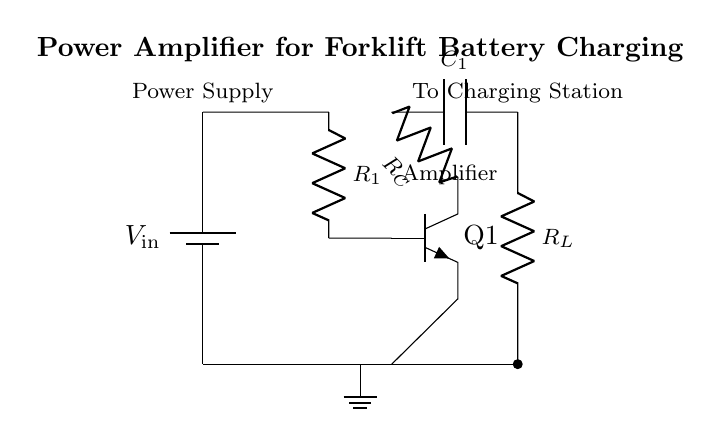What is the input voltage of the circuit? The input voltage is labeled as \( V_{\text{in}} \) and is a key parameter in the circuit that determines the power supplied to the amplifier.
Answer: \( V_{\text{in}} \) What type of transistor is used in this circuit? The component labeled as Q1 is identified as an npn transistor, which is commonly used in amplifying configurations due to its ability to handle high current gain.
Answer: npn What is the role of capacitor C1 in the circuit? Capacitor C1 is primarily used for coupling, allowing AC signals to pass from the amplifier stage to the output while blocking DC, thus preserving the functionality of the amplifier.
Answer: Coupling What components are used in the output stage? The output stage of the circuit consists of the load resistor \( R_L \) which connects the output of the amplifier to the charging station.
Answer: \( R_L \) How many resistors are present in this circuit? There are two resistors in this specific amplifier circuit, \( R_1 \) in the input stage and \( R_C \) in the collector of the transistor, which are essential for setting the circuit conditions.
Answer: 2 What is the purpose of resistor R1? Resistor \( R_1 \) is used in the input stage to limit the current entering the transistor's base, thus controlling the operation of the amplifier and preventing damage to the transistor.
Answer: Current limiting What does the ground symbol represent in this circuit? The ground symbol indicates a common reference point for the circuit, ensuring that all voltage levels are measured relative to this point, which is essential for proper circuit operation.
Answer: Common reference 